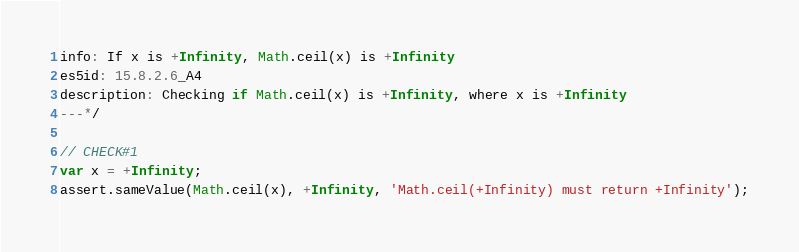Convert code to text. <code><loc_0><loc_0><loc_500><loc_500><_JavaScript_>info: If x is +Infinity, Math.ceil(x) is +Infinity
es5id: 15.8.2.6_A4
description: Checking if Math.ceil(x) is +Infinity, where x is +Infinity
---*/

// CHECK#1
var x = +Infinity;
assert.sameValue(Math.ceil(x), +Infinity, 'Math.ceil(+Infinity) must return +Infinity');
</code> 